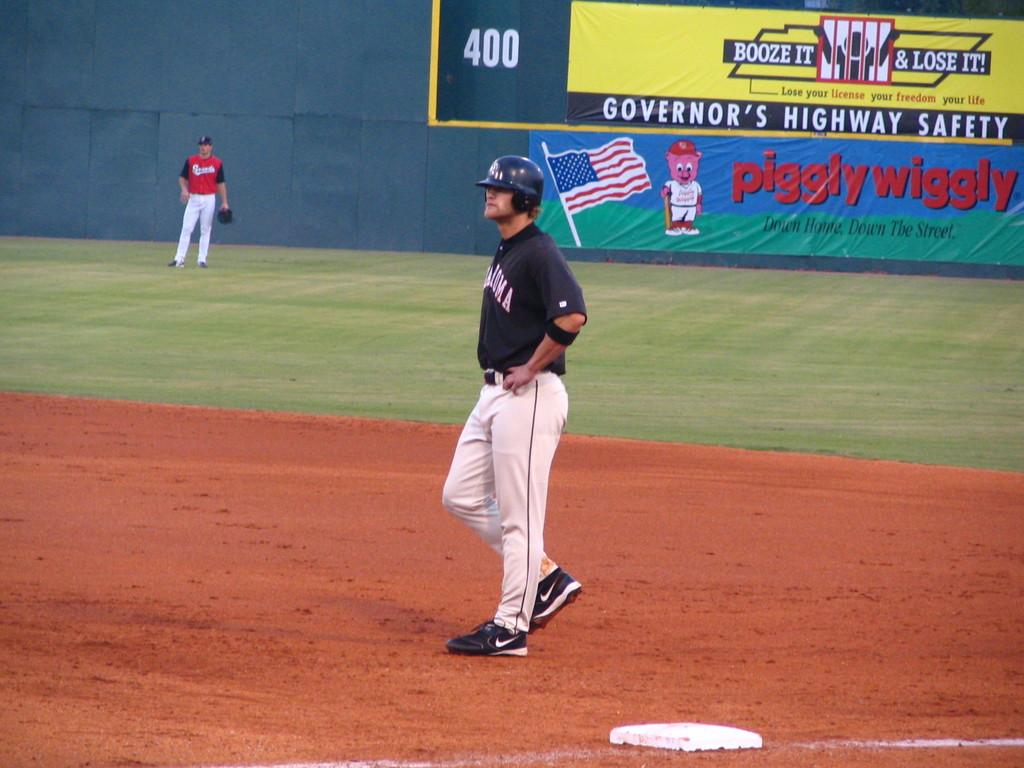Who wants highway safety?
Offer a very short reply. Governor. 